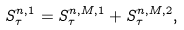<formula> <loc_0><loc_0><loc_500><loc_500>S ^ { n , 1 } _ { \tau } = S ^ { n , M , 1 } _ { \tau } + S ^ { n , M , 2 } _ { \tau } ,</formula> 